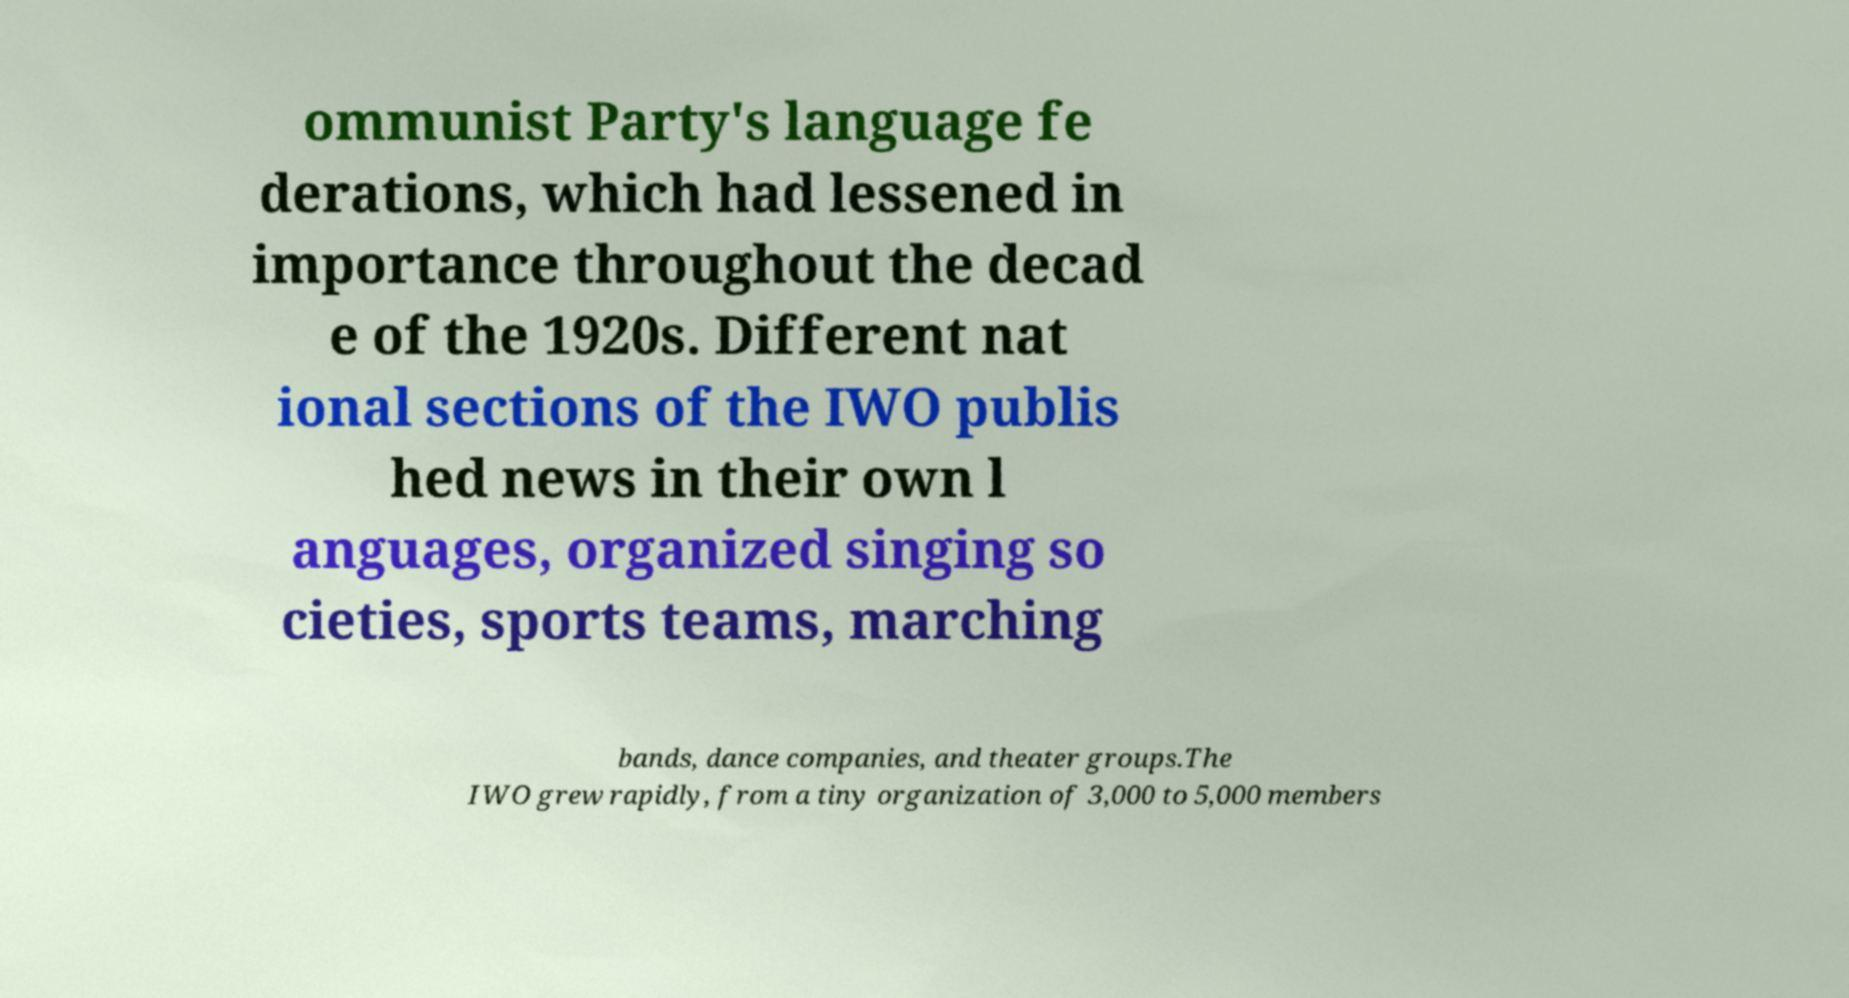Please identify and transcribe the text found in this image. ommunist Party's language fe derations, which had lessened in importance throughout the decad e of the 1920s. Different nat ional sections of the IWO publis hed news in their own l anguages, organized singing so cieties, sports teams, marching bands, dance companies, and theater groups.The IWO grew rapidly, from a tiny organization of 3,000 to 5,000 members 